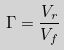<formula> <loc_0><loc_0><loc_500><loc_500>\Gamma = \frac { V _ { r } } { V _ { f } }</formula> 